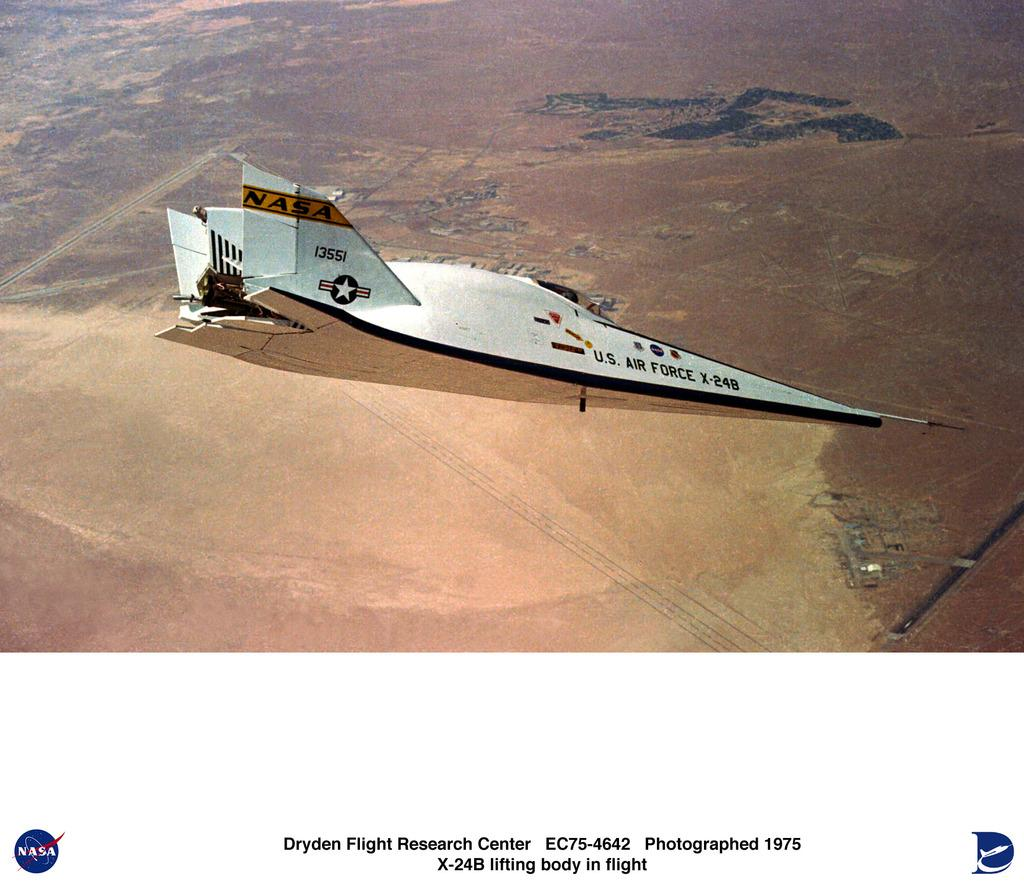What is the main subject of the picture? The main subject of the picture is a plane. Can you describe any additional details about the plane? Unfortunately, the provided facts do not offer any additional details about the plane. What is written or depicted at the bottom of the picture? There is text at the bottom of the picture. Can you tell me how many frogs are sitting on the plane's wing in the image? There are no frogs present in the image, so it is not possible to determine how many would be sitting on the plane's wing. 